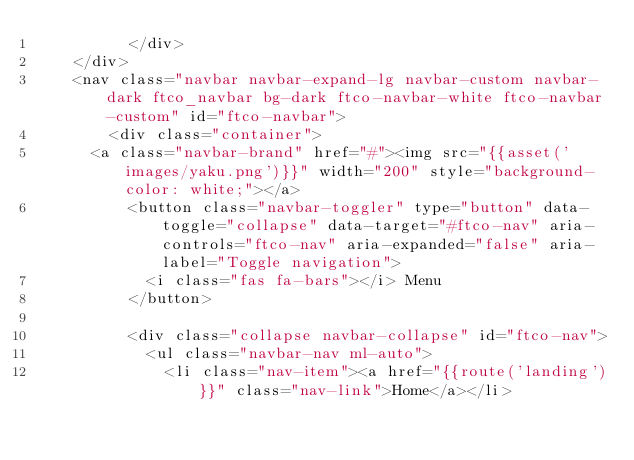<code> <loc_0><loc_0><loc_500><loc_500><_PHP_>		  </div>
    </div>
    <nav class="navbar navbar-expand-lg navbar-custom navbar-dark ftco_navbar bg-dark ftco-navbar-white ftco-navbar-custom" id="ftco-navbar">
	    <div class="container">
      <a class="navbar-brand" href="#"><img src="{{asset('images/yaku.png')}}" width="200" style="background-color: white;"></a>
	      <button class="navbar-toggler" type="button" data-toggle="collapse" data-target="#ftco-nav" aria-controls="ftco-nav" aria-expanded="false" aria-label="Toggle navigation">
	        <i class="fas fa-bars"></i> Menu
	      </button>

	      <div class="collapse navbar-collapse" id="ftco-nav">
	        <ul class="navbar-nav ml-auto">
	          <li class="nav-item"><a href="{{route('landing')}}" class="nav-link">Home</a></li>
		</code> 